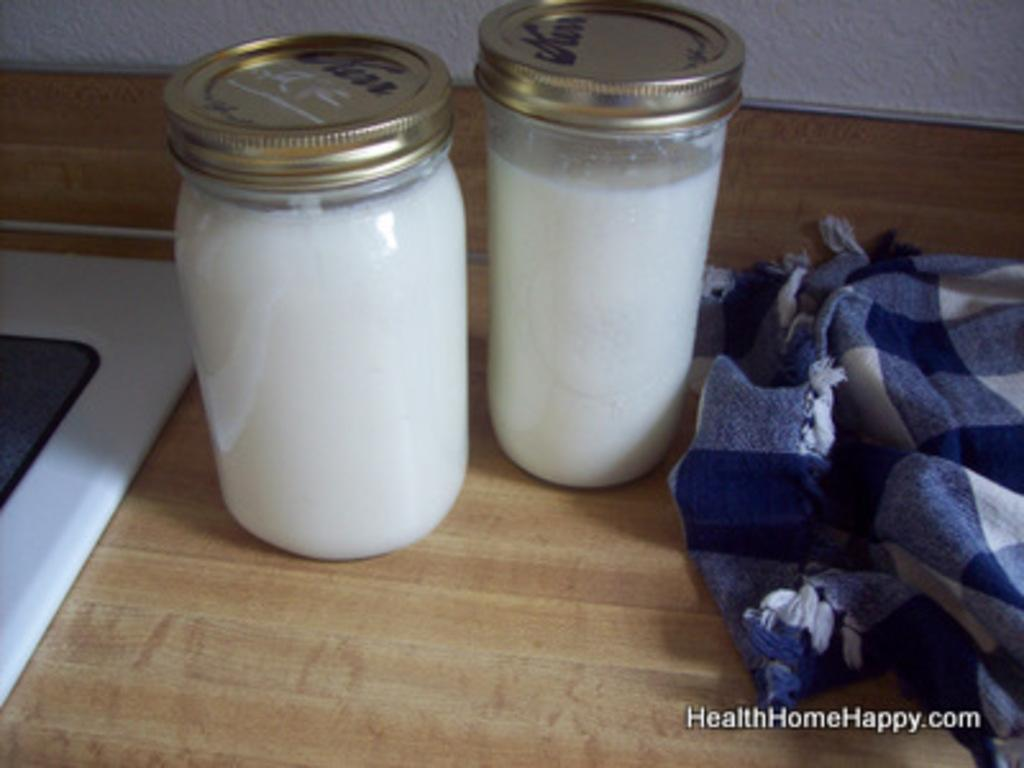What is inside the bottles that are visible in the image? There are bottles with a drink in the image. What else can be seen beside the bottles in the image? There is a cloth beside the bottles in the image. What type of bears can be seen interacting with the bottles in the image? There are no bears present in the image; it only features bottles with a drink and a cloth. 